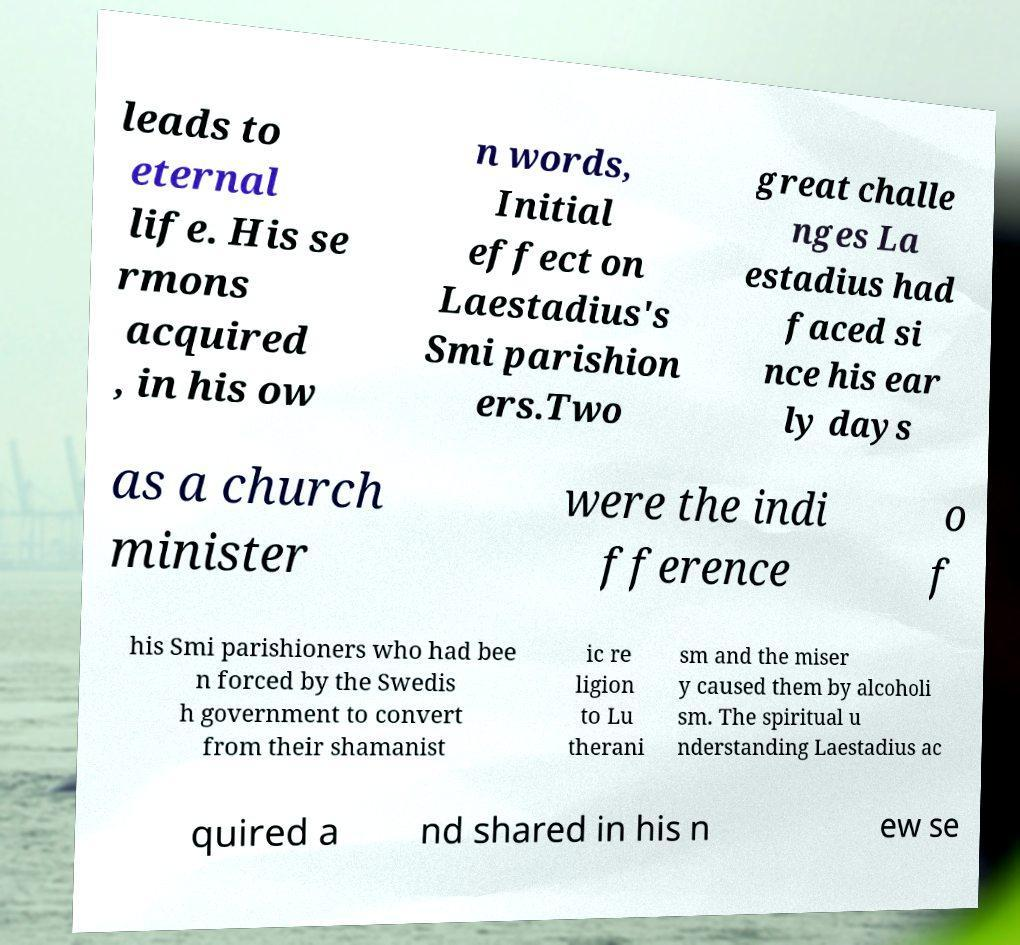Could you assist in decoding the text presented in this image and type it out clearly? leads to eternal life. His se rmons acquired , in his ow n words, Initial effect on Laestadius's Smi parishion ers.Two great challe nges La estadius had faced si nce his ear ly days as a church minister were the indi fference o f his Smi parishioners who had bee n forced by the Swedis h government to convert from their shamanist ic re ligion to Lu therani sm and the miser y caused them by alcoholi sm. The spiritual u nderstanding Laestadius ac quired a nd shared in his n ew se 